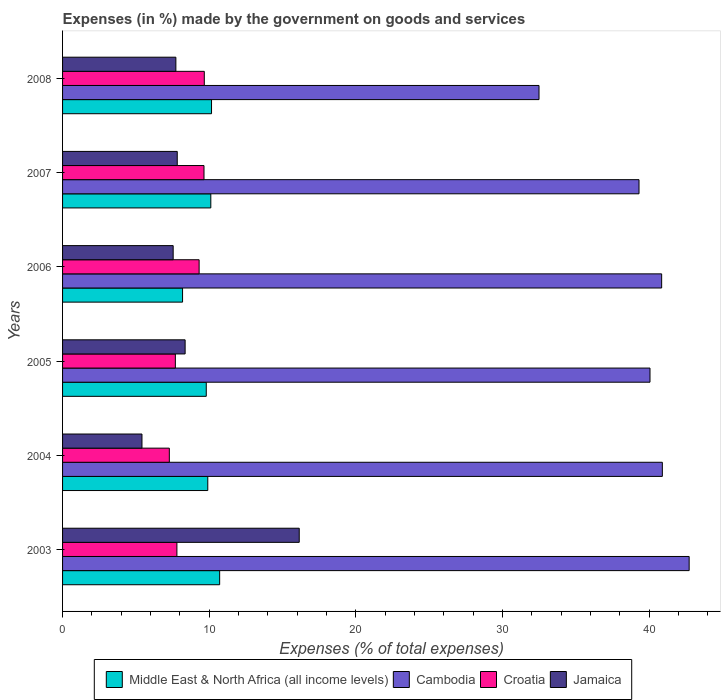How many different coloured bars are there?
Make the answer very short. 4. Are the number of bars per tick equal to the number of legend labels?
Your answer should be compact. Yes. How many bars are there on the 2nd tick from the top?
Provide a succinct answer. 4. What is the label of the 2nd group of bars from the top?
Provide a succinct answer. 2007. In how many cases, is the number of bars for a given year not equal to the number of legend labels?
Keep it short and to the point. 0. What is the percentage of expenses made by the government on goods and services in Croatia in 2006?
Your answer should be compact. 9.31. Across all years, what is the maximum percentage of expenses made by the government on goods and services in Jamaica?
Your answer should be very brief. 16.14. Across all years, what is the minimum percentage of expenses made by the government on goods and services in Middle East & North Africa (all income levels)?
Your answer should be very brief. 8.18. What is the total percentage of expenses made by the government on goods and services in Jamaica in the graph?
Ensure brevity in your answer.  52.99. What is the difference between the percentage of expenses made by the government on goods and services in Croatia in 2003 and that in 2004?
Make the answer very short. 0.52. What is the difference between the percentage of expenses made by the government on goods and services in Jamaica in 2004 and the percentage of expenses made by the government on goods and services in Croatia in 2007?
Your answer should be very brief. -4.23. What is the average percentage of expenses made by the government on goods and services in Jamaica per year?
Give a very brief answer. 8.83. In the year 2007, what is the difference between the percentage of expenses made by the government on goods and services in Croatia and percentage of expenses made by the government on goods and services in Middle East & North Africa (all income levels)?
Make the answer very short. -0.46. In how many years, is the percentage of expenses made by the government on goods and services in Cambodia greater than 20 %?
Ensure brevity in your answer.  6. What is the ratio of the percentage of expenses made by the government on goods and services in Cambodia in 2003 to that in 2008?
Offer a very short reply. 1.32. What is the difference between the highest and the second highest percentage of expenses made by the government on goods and services in Cambodia?
Make the answer very short. 1.83. What is the difference between the highest and the lowest percentage of expenses made by the government on goods and services in Croatia?
Offer a terse response. 2.38. In how many years, is the percentage of expenses made by the government on goods and services in Cambodia greater than the average percentage of expenses made by the government on goods and services in Cambodia taken over all years?
Make the answer very short. 4. Is the sum of the percentage of expenses made by the government on goods and services in Jamaica in 2005 and 2008 greater than the maximum percentage of expenses made by the government on goods and services in Cambodia across all years?
Your answer should be compact. No. Is it the case that in every year, the sum of the percentage of expenses made by the government on goods and services in Cambodia and percentage of expenses made by the government on goods and services in Croatia is greater than the sum of percentage of expenses made by the government on goods and services in Middle East & North Africa (all income levels) and percentage of expenses made by the government on goods and services in Jamaica?
Your answer should be very brief. Yes. What does the 1st bar from the top in 2007 represents?
Make the answer very short. Jamaica. What does the 1st bar from the bottom in 2007 represents?
Ensure brevity in your answer.  Middle East & North Africa (all income levels). How many bars are there?
Your response must be concise. 24. Are all the bars in the graph horizontal?
Provide a short and direct response. Yes. How are the legend labels stacked?
Keep it short and to the point. Horizontal. What is the title of the graph?
Ensure brevity in your answer.  Expenses (in %) made by the government on goods and services. What is the label or title of the X-axis?
Offer a very short reply. Expenses (% of total expenses). What is the label or title of the Y-axis?
Keep it short and to the point. Years. What is the Expenses (% of total expenses) in Middle East & North Africa (all income levels) in 2003?
Offer a very short reply. 10.71. What is the Expenses (% of total expenses) of Cambodia in 2003?
Provide a succinct answer. 42.72. What is the Expenses (% of total expenses) of Croatia in 2003?
Make the answer very short. 7.79. What is the Expenses (% of total expenses) of Jamaica in 2003?
Your answer should be compact. 16.14. What is the Expenses (% of total expenses) of Middle East & North Africa (all income levels) in 2004?
Offer a terse response. 9.9. What is the Expenses (% of total expenses) of Cambodia in 2004?
Provide a short and direct response. 40.89. What is the Expenses (% of total expenses) in Croatia in 2004?
Your response must be concise. 7.28. What is the Expenses (% of total expenses) of Jamaica in 2004?
Make the answer very short. 5.41. What is the Expenses (% of total expenses) of Middle East & North Africa (all income levels) in 2005?
Offer a very short reply. 9.8. What is the Expenses (% of total expenses) in Cambodia in 2005?
Your answer should be compact. 40.05. What is the Expenses (% of total expenses) of Croatia in 2005?
Your response must be concise. 7.69. What is the Expenses (% of total expenses) of Jamaica in 2005?
Your answer should be very brief. 8.36. What is the Expenses (% of total expenses) of Middle East & North Africa (all income levels) in 2006?
Give a very brief answer. 8.18. What is the Expenses (% of total expenses) of Cambodia in 2006?
Offer a very short reply. 40.84. What is the Expenses (% of total expenses) of Croatia in 2006?
Make the answer very short. 9.31. What is the Expenses (% of total expenses) in Jamaica in 2006?
Ensure brevity in your answer.  7.54. What is the Expenses (% of total expenses) in Middle East & North Africa (all income levels) in 2007?
Your answer should be compact. 10.11. What is the Expenses (% of total expenses) of Cambodia in 2007?
Your answer should be very brief. 39.3. What is the Expenses (% of total expenses) of Croatia in 2007?
Offer a very short reply. 9.64. What is the Expenses (% of total expenses) in Jamaica in 2007?
Make the answer very short. 7.82. What is the Expenses (% of total expenses) in Middle East & North Africa (all income levels) in 2008?
Offer a very short reply. 10.16. What is the Expenses (% of total expenses) in Cambodia in 2008?
Provide a short and direct response. 32.48. What is the Expenses (% of total expenses) in Croatia in 2008?
Your response must be concise. 9.66. What is the Expenses (% of total expenses) of Jamaica in 2008?
Ensure brevity in your answer.  7.72. Across all years, what is the maximum Expenses (% of total expenses) in Middle East & North Africa (all income levels)?
Provide a short and direct response. 10.71. Across all years, what is the maximum Expenses (% of total expenses) of Cambodia?
Keep it short and to the point. 42.72. Across all years, what is the maximum Expenses (% of total expenses) of Croatia?
Your answer should be compact. 9.66. Across all years, what is the maximum Expenses (% of total expenses) in Jamaica?
Your answer should be compact. 16.14. Across all years, what is the minimum Expenses (% of total expenses) in Middle East & North Africa (all income levels)?
Keep it short and to the point. 8.18. Across all years, what is the minimum Expenses (% of total expenses) of Cambodia?
Make the answer very short. 32.48. Across all years, what is the minimum Expenses (% of total expenses) in Croatia?
Make the answer very short. 7.28. Across all years, what is the minimum Expenses (% of total expenses) of Jamaica?
Provide a short and direct response. 5.41. What is the total Expenses (% of total expenses) of Middle East & North Africa (all income levels) in the graph?
Your answer should be compact. 58.85. What is the total Expenses (% of total expenses) of Cambodia in the graph?
Provide a short and direct response. 236.28. What is the total Expenses (% of total expenses) in Croatia in the graph?
Provide a succinct answer. 51.38. What is the total Expenses (% of total expenses) in Jamaica in the graph?
Offer a terse response. 52.99. What is the difference between the Expenses (% of total expenses) of Middle East & North Africa (all income levels) in 2003 and that in 2004?
Ensure brevity in your answer.  0.81. What is the difference between the Expenses (% of total expenses) in Cambodia in 2003 and that in 2004?
Offer a terse response. 1.83. What is the difference between the Expenses (% of total expenses) in Croatia in 2003 and that in 2004?
Ensure brevity in your answer.  0.52. What is the difference between the Expenses (% of total expenses) of Jamaica in 2003 and that in 2004?
Your answer should be very brief. 10.72. What is the difference between the Expenses (% of total expenses) in Middle East & North Africa (all income levels) in 2003 and that in 2005?
Ensure brevity in your answer.  0.91. What is the difference between the Expenses (% of total expenses) in Cambodia in 2003 and that in 2005?
Your response must be concise. 2.67. What is the difference between the Expenses (% of total expenses) of Croatia in 2003 and that in 2005?
Keep it short and to the point. 0.11. What is the difference between the Expenses (% of total expenses) in Jamaica in 2003 and that in 2005?
Your answer should be compact. 7.78. What is the difference between the Expenses (% of total expenses) in Middle East & North Africa (all income levels) in 2003 and that in 2006?
Your answer should be very brief. 2.53. What is the difference between the Expenses (% of total expenses) in Cambodia in 2003 and that in 2006?
Provide a short and direct response. 1.88. What is the difference between the Expenses (% of total expenses) of Croatia in 2003 and that in 2006?
Make the answer very short. -1.52. What is the difference between the Expenses (% of total expenses) of Jamaica in 2003 and that in 2006?
Provide a succinct answer. 8.59. What is the difference between the Expenses (% of total expenses) of Middle East & North Africa (all income levels) in 2003 and that in 2007?
Your answer should be compact. 0.6. What is the difference between the Expenses (% of total expenses) in Cambodia in 2003 and that in 2007?
Make the answer very short. 3.42. What is the difference between the Expenses (% of total expenses) of Croatia in 2003 and that in 2007?
Ensure brevity in your answer.  -1.85. What is the difference between the Expenses (% of total expenses) of Jamaica in 2003 and that in 2007?
Offer a very short reply. 8.32. What is the difference between the Expenses (% of total expenses) in Middle East & North Africa (all income levels) in 2003 and that in 2008?
Your answer should be compact. 0.55. What is the difference between the Expenses (% of total expenses) of Cambodia in 2003 and that in 2008?
Offer a terse response. 10.24. What is the difference between the Expenses (% of total expenses) in Croatia in 2003 and that in 2008?
Provide a succinct answer. -1.87. What is the difference between the Expenses (% of total expenses) of Jamaica in 2003 and that in 2008?
Your answer should be compact. 8.41. What is the difference between the Expenses (% of total expenses) of Middle East & North Africa (all income levels) in 2004 and that in 2005?
Make the answer very short. 0.1. What is the difference between the Expenses (% of total expenses) in Cambodia in 2004 and that in 2005?
Your answer should be very brief. 0.84. What is the difference between the Expenses (% of total expenses) of Croatia in 2004 and that in 2005?
Provide a short and direct response. -0.41. What is the difference between the Expenses (% of total expenses) of Jamaica in 2004 and that in 2005?
Keep it short and to the point. -2.94. What is the difference between the Expenses (% of total expenses) in Middle East & North Africa (all income levels) in 2004 and that in 2006?
Keep it short and to the point. 1.72. What is the difference between the Expenses (% of total expenses) of Cambodia in 2004 and that in 2006?
Provide a short and direct response. 0.05. What is the difference between the Expenses (% of total expenses) in Croatia in 2004 and that in 2006?
Offer a very short reply. -2.03. What is the difference between the Expenses (% of total expenses) in Jamaica in 2004 and that in 2006?
Offer a very short reply. -2.13. What is the difference between the Expenses (% of total expenses) in Middle East & North Africa (all income levels) in 2004 and that in 2007?
Give a very brief answer. -0.21. What is the difference between the Expenses (% of total expenses) in Cambodia in 2004 and that in 2007?
Your response must be concise. 1.59. What is the difference between the Expenses (% of total expenses) of Croatia in 2004 and that in 2007?
Your answer should be compact. -2.36. What is the difference between the Expenses (% of total expenses) in Jamaica in 2004 and that in 2007?
Provide a succinct answer. -2.4. What is the difference between the Expenses (% of total expenses) of Middle East & North Africa (all income levels) in 2004 and that in 2008?
Provide a short and direct response. -0.26. What is the difference between the Expenses (% of total expenses) in Cambodia in 2004 and that in 2008?
Give a very brief answer. 8.41. What is the difference between the Expenses (% of total expenses) in Croatia in 2004 and that in 2008?
Provide a succinct answer. -2.38. What is the difference between the Expenses (% of total expenses) in Jamaica in 2004 and that in 2008?
Keep it short and to the point. -2.31. What is the difference between the Expenses (% of total expenses) in Middle East & North Africa (all income levels) in 2005 and that in 2006?
Offer a very short reply. 1.62. What is the difference between the Expenses (% of total expenses) in Cambodia in 2005 and that in 2006?
Your answer should be very brief. -0.79. What is the difference between the Expenses (% of total expenses) of Croatia in 2005 and that in 2006?
Ensure brevity in your answer.  -1.62. What is the difference between the Expenses (% of total expenses) of Jamaica in 2005 and that in 2006?
Offer a terse response. 0.82. What is the difference between the Expenses (% of total expenses) of Middle East & North Africa (all income levels) in 2005 and that in 2007?
Give a very brief answer. -0.31. What is the difference between the Expenses (% of total expenses) of Cambodia in 2005 and that in 2007?
Your response must be concise. 0.75. What is the difference between the Expenses (% of total expenses) of Croatia in 2005 and that in 2007?
Make the answer very short. -1.95. What is the difference between the Expenses (% of total expenses) of Jamaica in 2005 and that in 2007?
Ensure brevity in your answer.  0.54. What is the difference between the Expenses (% of total expenses) of Middle East & North Africa (all income levels) in 2005 and that in 2008?
Your response must be concise. -0.36. What is the difference between the Expenses (% of total expenses) in Cambodia in 2005 and that in 2008?
Your answer should be very brief. 7.57. What is the difference between the Expenses (% of total expenses) of Croatia in 2005 and that in 2008?
Ensure brevity in your answer.  -1.97. What is the difference between the Expenses (% of total expenses) in Jamaica in 2005 and that in 2008?
Offer a terse response. 0.63. What is the difference between the Expenses (% of total expenses) in Middle East & North Africa (all income levels) in 2006 and that in 2007?
Your response must be concise. -1.93. What is the difference between the Expenses (% of total expenses) in Cambodia in 2006 and that in 2007?
Give a very brief answer. 1.54. What is the difference between the Expenses (% of total expenses) in Croatia in 2006 and that in 2007?
Give a very brief answer. -0.33. What is the difference between the Expenses (% of total expenses) of Jamaica in 2006 and that in 2007?
Give a very brief answer. -0.28. What is the difference between the Expenses (% of total expenses) in Middle East & North Africa (all income levels) in 2006 and that in 2008?
Provide a short and direct response. -1.98. What is the difference between the Expenses (% of total expenses) of Cambodia in 2006 and that in 2008?
Make the answer very short. 8.36. What is the difference between the Expenses (% of total expenses) in Croatia in 2006 and that in 2008?
Provide a short and direct response. -0.35. What is the difference between the Expenses (% of total expenses) in Jamaica in 2006 and that in 2008?
Offer a very short reply. -0.18. What is the difference between the Expenses (% of total expenses) in Middle East & North Africa (all income levels) in 2007 and that in 2008?
Provide a short and direct response. -0.05. What is the difference between the Expenses (% of total expenses) of Cambodia in 2007 and that in 2008?
Your answer should be compact. 6.82. What is the difference between the Expenses (% of total expenses) of Croatia in 2007 and that in 2008?
Your answer should be very brief. -0.02. What is the difference between the Expenses (% of total expenses) in Jamaica in 2007 and that in 2008?
Offer a very short reply. 0.09. What is the difference between the Expenses (% of total expenses) in Middle East & North Africa (all income levels) in 2003 and the Expenses (% of total expenses) in Cambodia in 2004?
Give a very brief answer. -30.18. What is the difference between the Expenses (% of total expenses) in Middle East & North Africa (all income levels) in 2003 and the Expenses (% of total expenses) in Croatia in 2004?
Your answer should be compact. 3.43. What is the difference between the Expenses (% of total expenses) of Middle East & North Africa (all income levels) in 2003 and the Expenses (% of total expenses) of Jamaica in 2004?
Your answer should be very brief. 5.3. What is the difference between the Expenses (% of total expenses) in Cambodia in 2003 and the Expenses (% of total expenses) in Croatia in 2004?
Provide a short and direct response. 35.44. What is the difference between the Expenses (% of total expenses) in Cambodia in 2003 and the Expenses (% of total expenses) in Jamaica in 2004?
Ensure brevity in your answer.  37.3. What is the difference between the Expenses (% of total expenses) of Croatia in 2003 and the Expenses (% of total expenses) of Jamaica in 2004?
Give a very brief answer. 2.38. What is the difference between the Expenses (% of total expenses) in Middle East & North Africa (all income levels) in 2003 and the Expenses (% of total expenses) in Cambodia in 2005?
Ensure brevity in your answer.  -29.34. What is the difference between the Expenses (% of total expenses) of Middle East & North Africa (all income levels) in 2003 and the Expenses (% of total expenses) of Croatia in 2005?
Make the answer very short. 3.02. What is the difference between the Expenses (% of total expenses) of Middle East & North Africa (all income levels) in 2003 and the Expenses (% of total expenses) of Jamaica in 2005?
Ensure brevity in your answer.  2.35. What is the difference between the Expenses (% of total expenses) in Cambodia in 2003 and the Expenses (% of total expenses) in Croatia in 2005?
Your answer should be very brief. 35.03. What is the difference between the Expenses (% of total expenses) in Cambodia in 2003 and the Expenses (% of total expenses) in Jamaica in 2005?
Your answer should be compact. 34.36. What is the difference between the Expenses (% of total expenses) of Croatia in 2003 and the Expenses (% of total expenses) of Jamaica in 2005?
Offer a very short reply. -0.56. What is the difference between the Expenses (% of total expenses) in Middle East & North Africa (all income levels) in 2003 and the Expenses (% of total expenses) in Cambodia in 2006?
Give a very brief answer. -30.13. What is the difference between the Expenses (% of total expenses) in Middle East & North Africa (all income levels) in 2003 and the Expenses (% of total expenses) in Croatia in 2006?
Ensure brevity in your answer.  1.4. What is the difference between the Expenses (% of total expenses) of Middle East & North Africa (all income levels) in 2003 and the Expenses (% of total expenses) of Jamaica in 2006?
Give a very brief answer. 3.17. What is the difference between the Expenses (% of total expenses) of Cambodia in 2003 and the Expenses (% of total expenses) of Croatia in 2006?
Give a very brief answer. 33.41. What is the difference between the Expenses (% of total expenses) in Cambodia in 2003 and the Expenses (% of total expenses) in Jamaica in 2006?
Your answer should be very brief. 35.18. What is the difference between the Expenses (% of total expenses) in Croatia in 2003 and the Expenses (% of total expenses) in Jamaica in 2006?
Provide a succinct answer. 0.25. What is the difference between the Expenses (% of total expenses) of Middle East & North Africa (all income levels) in 2003 and the Expenses (% of total expenses) of Cambodia in 2007?
Your response must be concise. -28.59. What is the difference between the Expenses (% of total expenses) of Middle East & North Africa (all income levels) in 2003 and the Expenses (% of total expenses) of Croatia in 2007?
Your response must be concise. 1.07. What is the difference between the Expenses (% of total expenses) in Middle East & North Africa (all income levels) in 2003 and the Expenses (% of total expenses) in Jamaica in 2007?
Your answer should be compact. 2.89. What is the difference between the Expenses (% of total expenses) in Cambodia in 2003 and the Expenses (% of total expenses) in Croatia in 2007?
Your answer should be very brief. 33.08. What is the difference between the Expenses (% of total expenses) of Cambodia in 2003 and the Expenses (% of total expenses) of Jamaica in 2007?
Ensure brevity in your answer.  34.9. What is the difference between the Expenses (% of total expenses) in Croatia in 2003 and the Expenses (% of total expenses) in Jamaica in 2007?
Offer a terse response. -0.02. What is the difference between the Expenses (% of total expenses) of Middle East & North Africa (all income levels) in 2003 and the Expenses (% of total expenses) of Cambodia in 2008?
Your answer should be very brief. -21.77. What is the difference between the Expenses (% of total expenses) in Middle East & North Africa (all income levels) in 2003 and the Expenses (% of total expenses) in Croatia in 2008?
Your response must be concise. 1.05. What is the difference between the Expenses (% of total expenses) of Middle East & North Africa (all income levels) in 2003 and the Expenses (% of total expenses) of Jamaica in 2008?
Offer a very short reply. 2.99. What is the difference between the Expenses (% of total expenses) in Cambodia in 2003 and the Expenses (% of total expenses) in Croatia in 2008?
Your answer should be very brief. 33.06. What is the difference between the Expenses (% of total expenses) in Cambodia in 2003 and the Expenses (% of total expenses) in Jamaica in 2008?
Provide a short and direct response. 34.99. What is the difference between the Expenses (% of total expenses) of Croatia in 2003 and the Expenses (% of total expenses) of Jamaica in 2008?
Offer a very short reply. 0.07. What is the difference between the Expenses (% of total expenses) in Middle East & North Africa (all income levels) in 2004 and the Expenses (% of total expenses) in Cambodia in 2005?
Your answer should be very brief. -30.15. What is the difference between the Expenses (% of total expenses) in Middle East & North Africa (all income levels) in 2004 and the Expenses (% of total expenses) in Croatia in 2005?
Provide a short and direct response. 2.21. What is the difference between the Expenses (% of total expenses) of Middle East & North Africa (all income levels) in 2004 and the Expenses (% of total expenses) of Jamaica in 2005?
Your response must be concise. 1.54. What is the difference between the Expenses (% of total expenses) of Cambodia in 2004 and the Expenses (% of total expenses) of Croatia in 2005?
Keep it short and to the point. 33.2. What is the difference between the Expenses (% of total expenses) in Cambodia in 2004 and the Expenses (% of total expenses) in Jamaica in 2005?
Your response must be concise. 32.53. What is the difference between the Expenses (% of total expenses) of Croatia in 2004 and the Expenses (% of total expenses) of Jamaica in 2005?
Ensure brevity in your answer.  -1.08. What is the difference between the Expenses (% of total expenses) of Middle East & North Africa (all income levels) in 2004 and the Expenses (% of total expenses) of Cambodia in 2006?
Make the answer very short. -30.94. What is the difference between the Expenses (% of total expenses) of Middle East & North Africa (all income levels) in 2004 and the Expenses (% of total expenses) of Croatia in 2006?
Provide a short and direct response. 0.59. What is the difference between the Expenses (% of total expenses) of Middle East & North Africa (all income levels) in 2004 and the Expenses (% of total expenses) of Jamaica in 2006?
Offer a very short reply. 2.36. What is the difference between the Expenses (% of total expenses) of Cambodia in 2004 and the Expenses (% of total expenses) of Croatia in 2006?
Make the answer very short. 31.58. What is the difference between the Expenses (% of total expenses) of Cambodia in 2004 and the Expenses (% of total expenses) of Jamaica in 2006?
Give a very brief answer. 33.35. What is the difference between the Expenses (% of total expenses) in Croatia in 2004 and the Expenses (% of total expenses) in Jamaica in 2006?
Keep it short and to the point. -0.26. What is the difference between the Expenses (% of total expenses) of Middle East & North Africa (all income levels) in 2004 and the Expenses (% of total expenses) of Cambodia in 2007?
Make the answer very short. -29.4. What is the difference between the Expenses (% of total expenses) in Middle East & North Africa (all income levels) in 2004 and the Expenses (% of total expenses) in Croatia in 2007?
Give a very brief answer. 0.26. What is the difference between the Expenses (% of total expenses) in Middle East & North Africa (all income levels) in 2004 and the Expenses (% of total expenses) in Jamaica in 2007?
Your response must be concise. 2.08. What is the difference between the Expenses (% of total expenses) of Cambodia in 2004 and the Expenses (% of total expenses) of Croatia in 2007?
Keep it short and to the point. 31.25. What is the difference between the Expenses (% of total expenses) of Cambodia in 2004 and the Expenses (% of total expenses) of Jamaica in 2007?
Offer a very short reply. 33.07. What is the difference between the Expenses (% of total expenses) in Croatia in 2004 and the Expenses (% of total expenses) in Jamaica in 2007?
Keep it short and to the point. -0.54. What is the difference between the Expenses (% of total expenses) of Middle East & North Africa (all income levels) in 2004 and the Expenses (% of total expenses) of Cambodia in 2008?
Ensure brevity in your answer.  -22.58. What is the difference between the Expenses (% of total expenses) in Middle East & North Africa (all income levels) in 2004 and the Expenses (% of total expenses) in Croatia in 2008?
Your response must be concise. 0.24. What is the difference between the Expenses (% of total expenses) of Middle East & North Africa (all income levels) in 2004 and the Expenses (% of total expenses) of Jamaica in 2008?
Ensure brevity in your answer.  2.18. What is the difference between the Expenses (% of total expenses) of Cambodia in 2004 and the Expenses (% of total expenses) of Croatia in 2008?
Your response must be concise. 31.23. What is the difference between the Expenses (% of total expenses) of Cambodia in 2004 and the Expenses (% of total expenses) of Jamaica in 2008?
Your response must be concise. 33.17. What is the difference between the Expenses (% of total expenses) of Croatia in 2004 and the Expenses (% of total expenses) of Jamaica in 2008?
Ensure brevity in your answer.  -0.45. What is the difference between the Expenses (% of total expenses) of Middle East & North Africa (all income levels) in 2005 and the Expenses (% of total expenses) of Cambodia in 2006?
Your response must be concise. -31.05. What is the difference between the Expenses (% of total expenses) of Middle East & North Africa (all income levels) in 2005 and the Expenses (% of total expenses) of Croatia in 2006?
Provide a succinct answer. 0.49. What is the difference between the Expenses (% of total expenses) in Middle East & North Africa (all income levels) in 2005 and the Expenses (% of total expenses) in Jamaica in 2006?
Provide a short and direct response. 2.26. What is the difference between the Expenses (% of total expenses) in Cambodia in 2005 and the Expenses (% of total expenses) in Croatia in 2006?
Make the answer very short. 30.74. What is the difference between the Expenses (% of total expenses) of Cambodia in 2005 and the Expenses (% of total expenses) of Jamaica in 2006?
Provide a short and direct response. 32.51. What is the difference between the Expenses (% of total expenses) in Croatia in 2005 and the Expenses (% of total expenses) in Jamaica in 2006?
Your answer should be very brief. 0.15. What is the difference between the Expenses (% of total expenses) in Middle East & North Africa (all income levels) in 2005 and the Expenses (% of total expenses) in Cambodia in 2007?
Your answer should be compact. -29.5. What is the difference between the Expenses (% of total expenses) of Middle East & North Africa (all income levels) in 2005 and the Expenses (% of total expenses) of Croatia in 2007?
Your response must be concise. 0.15. What is the difference between the Expenses (% of total expenses) of Middle East & North Africa (all income levels) in 2005 and the Expenses (% of total expenses) of Jamaica in 2007?
Keep it short and to the point. 1.98. What is the difference between the Expenses (% of total expenses) in Cambodia in 2005 and the Expenses (% of total expenses) in Croatia in 2007?
Keep it short and to the point. 30.41. What is the difference between the Expenses (% of total expenses) in Cambodia in 2005 and the Expenses (% of total expenses) in Jamaica in 2007?
Provide a short and direct response. 32.23. What is the difference between the Expenses (% of total expenses) in Croatia in 2005 and the Expenses (% of total expenses) in Jamaica in 2007?
Offer a terse response. -0.13. What is the difference between the Expenses (% of total expenses) of Middle East & North Africa (all income levels) in 2005 and the Expenses (% of total expenses) of Cambodia in 2008?
Your response must be concise. -22.69. What is the difference between the Expenses (% of total expenses) in Middle East & North Africa (all income levels) in 2005 and the Expenses (% of total expenses) in Croatia in 2008?
Your answer should be very brief. 0.13. What is the difference between the Expenses (% of total expenses) in Middle East & North Africa (all income levels) in 2005 and the Expenses (% of total expenses) in Jamaica in 2008?
Keep it short and to the point. 2.07. What is the difference between the Expenses (% of total expenses) of Cambodia in 2005 and the Expenses (% of total expenses) of Croatia in 2008?
Give a very brief answer. 30.39. What is the difference between the Expenses (% of total expenses) in Cambodia in 2005 and the Expenses (% of total expenses) in Jamaica in 2008?
Keep it short and to the point. 32.32. What is the difference between the Expenses (% of total expenses) in Croatia in 2005 and the Expenses (% of total expenses) in Jamaica in 2008?
Offer a very short reply. -0.03. What is the difference between the Expenses (% of total expenses) in Middle East & North Africa (all income levels) in 2006 and the Expenses (% of total expenses) in Cambodia in 2007?
Ensure brevity in your answer.  -31.12. What is the difference between the Expenses (% of total expenses) in Middle East & North Africa (all income levels) in 2006 and the Expenses (% of total expenses) in Croatia in 2007?
Provide a succinct answer. -1.46. What is the difference between the Expenses (% of total expenses) in Middle East & North Africa (all income levels) in 2006 and the Expenses (% of total expenses) in Jamaica in 2007?
Offer a very short reply. 0.36. What is the difference between the Expenses (% of total expenses) in Cambodia in 2006 and the Expenses (% of total expenses) in Croatia in 2007?
Provide a short and direct response. 31.2. What is the difference between the Expenses (% of total expenses) in Cambodia in 2006 and the Expenses (% of total expenses) in Jamaica in 2007?
Provide a short and direct response. 33.02. What is the difference between the Expenses (% of total expenses) of Croatia in 2006 and the Expenses (% of total expenses) of Jamaica in 2007?
Give a very brief answer. 1.49. What is the difference between the Expenses (% of total expenses) of Middle East & North Africa (all income levels) in 2006 and the Expenses (% of total expenses) of Cambodia in 2008?
Make the answer very short. -24.3. What is the difference between the Expenses (% of total expenses) in Middle East & North Africa (all income levels) in 2006 and the Expenses (% of total expenses) in Croatia in 2008?
Make the answer very short. -1.48. What is the difference between the Expenses (% of total expenses) of Middle East & North Africa (all income levels) in 2006 and the Expenses (% of total expenses) of Jamaica in 2008?
Provide a succinct answer. 0.46. What is the difference between the Expenses (% of total expenses) of Cambodia in 2006 and the Expenses (% of total expenses) of Croatia in 2008?
Ensure brevity in your answer.  31.18. What is the difference between the Expenses (% of total expenses) of Cambodia in 2006 and the Expenses (% of total expenses) of Jamaica in 2008?
Your answer should be compact. 33.12. What is the difference between the Expenses (% of total expenses) of Croatia in 2006 and the Expenses (% of total expenses) of Jamaica in 2008?
Your answer should be compact. 1.59. What is the difference between the Expenses (% of total expenses) of Middle East & North Africa (all income levels) in 2007 and the Expenses (% of total expenses) of Cambodia in 2008?
Provide a short and direct response. -22.38. What is the difference between the Expenses (% of total expenses) of Middle East & North Africa (all income levels) in 2007 and the Expenses (% of total expenses) of Croatia in 2008?
Keep it short and to the point. 0.44. What is the difference between the Expenses (% of total expenses) of Middle East & North Africa (all income levels) in 2007 and the Expenses (% of total expenses) of Jamaica in 2008?
Provide a short and direct response. 2.38. What is the difference between the Expenses (% of total expenses) of Cambodia in 2007 and the Expenses (% of total expenses) of Croatia in 2008?
Offer a terse response. 29.64. What is the difference between the Expenses (% of total expenses) in Cambodia in 2007 and the Expenses (% of total expenses) in Jamaica in 2008?
Your answer should be compact. 31.58. What is the difference between the Expenses (% of total expenses) of Croatia in 2007 and the Expenses (% of total expenses) of Jamaica in 2008?
Ensure brevity in your answer.  1.92. What is the average Expenses (% of total expenses) in Middle East & North Africa (all income levels) per year?
Ensure brevity in your answer.  9.81. What is the average Expenses (% of total expenses) in Cambodia per year?
Offer a very short reply. 39.38. What is the average Expenses (% of total expenses) of Croatia per year?
Ensure brevity in your answer.  8.56. What is the average Expenses (% of total expenses) of Jamaica per year?
Provide a succinct answer. 8.83. In the year 2003, what is the difference between the Expenses (% of total expenses) in Middle East & North Africa (all income levels) and Expenses (% of total expenses) in Cambodia?
Provide a short and direct response. -32.01. In the year 2003, what is the difference between the Expenses (% of total expenses) in Middle East & North Africa (all income levels) and Expenses (% of total expenses) in Croatia?
Make the answer very short. 2.92. In the year 2003, what is the difference between the Expenses (% of total expenses) in Middle East & North Africa (all income levels) and Expenses (% of total expenses) in Jamaica?
Keep it short and to the point. -5.43. In the year 2003, what is the difference between the Expenses (% of total expenses) of Cambodia and Expenses (% of total expenses) of Croatia?
Your response must be concise. 34.92. In the year 2003, what is the difference between the Expenses (% of total expenses) in Cambodia and Expenses (% of total expenses) in Jamaica?
Keep it short and to the point. 26.58. In the year 2003, what is the difference between the Expenses (% of total expenses) in Croatia and Expenses (% of total expenses) in Jamaica?
Give a very brief answer. -8.34. In the year 2004, what is the difference between the Expenses (% of total expenses) in Middle East & North Africa (all income levels) and Expenses (% of total expenses) in Cambodia?
Provide a succinct answer. -30.99. In the year 2004, what is the difference between the Expenses (% of total expenses) in Middle East & North Africa (all income levels) and Expenses (% of total expenses) in Croatia?
Make the answer very short. 2.62. In the year 2004, what is the difference between the Expenses (% of total expenses) of Middle East & North Africa (all income levels) and Expenses (% of total expenses) of Jamaica?
Offer a terse response. 4.49. In the year 2004, what is the difference between the Expenses (% of total expenses) of Cambodia and Expenses (% of total expenses) of Croatia?
Your response must be concise. 33.61. In the year 2004, what is the difference between the Expenses (% of total expenses) in Cambodia and Expenses (% of total expenses) in Jamaica?
Provide a short and direct response. 35.48. In the year 2004, what is the difference between the Expenses (% of total expenses) in Croatia and Expenses (% of total expenses) in Jamaica?
Your response must be concise. 1.86. In the year 2005, what is the difference between the Expenses (% of total expenses) of Middle East & North Africa (all income levels) and Expenses (% of total expenses) of Cambodia?
Make the answer very short. -30.25. In the year 2005, what is the difference between the Expenses (% of total expenses) of Middle East & North Africa (all income levels) and Expenses (% of total expenses) of Croatia?
Provide a succinct answer. 2.11. In the year 2005, what is the difference between the Expenses (% of total expenses) of Middle East & North Africa (all income levels) and Expenses (% of total expenses) of Jamaica?
Ensure brevity in your answer.  1.44. In the year 2005, what is the difference between the Expenses (% of total expenses) of Cambodia and Expenses (% of total expenses) of Croatia?
Offer a very short reply. 32.36. In the year 2005, what is the difference between the Expenses (% of total expenses) of Cambodia and Expenses (% of total expenses) of Jamaica?
Your response must be concise. 31.69. In the year 2005, what is the difference between the Expenses (% of total expenses) in Croatia and Expenses (% of total expenses) in Jamaica?
Make the answer very short. -0.67. In the year 2006, what is the difference between the Expenses (% of total expenses) in Middle East & North Africa (all income levels) and Expenses (% of total expenses) in Cambodia?
Offer a terse response. -32.66. In the year 2006, what is the difference between the Expenses (% of total expenses) of Middle East & North Africa (all income levels) and Expenses (% of total expenses) of Croatia?
Give a very brief answer. -1.13. In the year 2006, what is the difference between the Expenses (% of total expenses) of Middle East & North Africa (all income levels) and Expenses (% of total expenses) of Jamaica?
Offer a terse response. 0.64. In the year 2006, what is the difference between the Expenses (% of total expenses) of Cambodia and Expenses (% of total expenses) of Croatia?
Make the answer very short. 31.53. In the year 2006, what is the difference between the Expenses (% of total expenses) in Cambodia and Expenses (% of total expenses) in Jamaica?
Offer a terse response. 33.3. In the year 2006, what is the difference between the Expenses (% of total expenses) of Croatia and Expenses (% of total expenses) of Jamaica?
Your answer should be compact. 1.77. In the year 2007, what is the difference between the Expenses (% of total expenses) of Middle East & North Africa (all income levels) and Expenses (% of total expenses) of Cambodia?
Make the answer very short. -29.19. In the year 2007, what is the difference between the Expenses (% of total expenses) in Middle East & North Africa (all income levels) and Expenses (% of total expenses) in Croatia?
Offer a very short reply. 0.46. In the year 2007, what is the difference between the Expenses (% of total expenses) in Middle East & North Africa (all income levels) and Expenses (% of total expenses) in Jamaica?
Keep it short and to the point. 2.29. In the year 2007, what is the difference between the Expenses (% of total expenses) of Cambodia and Expenses (% of total expenses) of Croatia?
Keep it short and to the point. 29.66. In the year 2007, what is the difference between the Expenses (% of total expenses) in Cambodia and Expenses (% of total expenses) in Jamaica?
Make the answer very short. 31.48. In the year 2007, what is the difference between the Expenses (% of total expenses) of Croatia and Expenses (% of total expenses) of Jamaica?
Your answer should be very brief. 1.82. In the year 2008, what is the difference between the Expenses (% of total expenses) of Middle East & North Africa (all income levels) and Expenses (% of total expenses) of Cambodia?
Your answer should be compact. -22.33. In the year 2008, what is the difference between the Expenses (% of total expenses) of Middle East & North Africa (all income levels) and Expenses (% of total expenses) of Croatia?
Offer a terse response. 0.49. In the year 2008, what is the difference between the Expenses (% of total expenses) of Middle East & North Africa (all income levels) and Expenses (% of total expenses) of Jamaica?
Offer a terse response. 2.43. In the year 2008, what is the difference between the Expenses (% of total expenses) in Cambodia and Expenses (% of total expenses) in Croatia?
Offer a terse response. 22.82. In the year 2008, what is the difference between the Expenses (% of total expenses) in Cambodia and Expenses (% of total expenses) in Jamaica?
Your response must be concise. 24.76. In the year 2008, what is the difference between the Expenses (% of total expenses) in Croatia and Expenses (% of total expenses) in Jamaica?
Keep it short and to the point. 1.94. What is the ratio of the Expenses (% of total expenses) of Middle East & North Africa (all income levels) in 2003 to that in 2004?
Provide a short and direct response. 1.08. What is the ratio of the Expenses (% of total expenses) of Cambodia in 2003 to that in 2004?
Offer a very short reply. 1.04. What is the ratio of the Expenses (% of total expenses) of Croatia in 2003 to that in 2004?
Offer a very short reply. 1.07. What is the ratio of the Expenses (% of total expenses) of Jamaica in 2003 to that in 2004?
Offer a very short reply. 2.98. What is the ratio of the Expenses (% of total expenses) in Middle East & North Africa (all income levels) in 2003 to that in 2005?
Keep it short and to the point. 1.09. What is the ratio of the Expenses (% of total expenses) of Cambodia in 2003 to that in 2005?
Your answer should be very brief. 1.07. What is the ratio of the Expenses (% of total expenses) in Croatia in 2003 to that in 2005?
Your answer should be very brief. 1.01. What is the ratio of the Expenses (% of total expenses) of Jamaica in 2003 to that in 2005?
Your answer should be very brief. 1.93. What is the ratio of the Expenses (% of total expenses) of Middle East & North Africa (all income levels) in 2003 to that in 2006?
Make the answer very short. 1.31. What is the ratio of the Expenses (% of total expenses) of Cambodia in 2003 to that in 2006?
Keep it short and to the point. 1.05. What is the ratio of the Expenses (% of total expenses) in Croatia in 2003 to that in 2006?
Provide a short and direct response. 0.84. What is the ratio of the Expenses (% of total expenses) of Jamaica in 2003 to that in 2006?
Provide a short and direct response. 2.14. What is the ratio of the Expenses (% of total expenses) of Middle East & North Africa (all income levels) in 2003 to that in 2007?
Offer a terse response. 1.06. What is the ratio of the Expenses (% of total expenses) in Cambodia in 2003 to that in 2007?
Offer a very short reply. 1.09. What is the ratio of the Expenses (% of total expenses) of Croatia in 2003 to that in 2007?
Provide a succinct answer. 0.81. What is the ratio of the Expenses (% of total expenses) in Jamaica in 2003 to that in 2007?
Offer a terse response. 2.06. What is the ratio of the Expenses (% of total expenses) of Middle East & North Africa (all income levels) in 2003 to that in 2008?
Provide a short and direct response. 1.05. What is the ratio of the Expenses (% of total expenses) of Cambodia in 2003 to that in 2008?
Your response must be concise. 1.32. What is the ratio of the Expenses (% of total expenses) of Croatia in 2003 to that in 2008?
Offer a terse response. 0.81. What is the ratio of the Expenses (% of total expenses) of Jamaica in 2003 to that in 2008?
Your answer should be compact. 2.09. What is the ratio of the Expenses (% of total expenses) in Middle East & North Africa (all income levels) in 2004 to that in 2005?
Offer a terse response. 1.01. What is the ratio of the Expenses (% of total expenses) of Croatia in 2004 to that in 2005?
Offer a terse response. 0.95. What is the ratio of the Expenses (% of total expenses) in Jamaica in 2004 to that in 2005?
Offer a very short reply. 0.65. What is the ratio of the Expenses (% of total expenses) of Middle East & North Africa (all income levels) in 2004 to that in 2006?
Provide a succinct answer. 1.21. What is the ratio of the Expenses (% of total expenses) of Cambodia in 2004 to that in 2006?
Your response must be concise. 1. What is the ratio of the Expenses (% of total expenses) of Croatia in 2004 to that in 2006?
Your response must be concise. 0.78. What is the ratio of the Expenses (% of total expenses) in Jamaica in 2004 to that in 2006?
Ensure brevity in your answer.  0.72. What is the ratio of the Expenses (% of total expenses) in Middle East & North Africa (all income levels) in 2004 to that in 2007?
Your answer should be very brief. 0.98. What is the ratio of the Expenses (% of total expenses) in Cambodia in 2004 to that in 2007?
Your answer should be compact. 1.04. What is the ratio of the Expenses (% of total expenses) in Croatia in 2004 to that in 2007?
Make the answer very short. 0.75. What is the ratio of the Expenses (% of total expenses) of Jamaica in 2004 to that in 2007?
Give a very brief answer. 0.69. What is the ratio of the Expenses (% of total expenses) in Middle East & North Africa (all income levels) in 2004 to that in 2008?
Provide a short and direct response. 0.97. What is the ratio of the Expenses (% of total expenses) of Cambodia in 2004 to that in 2008?
Provide a succinct answer. 1.26. What is the ratio of the Expenses (% of total expenses) of Croatia in 2004 to that in 2008?
Make the answer very short. 0.75. What is the ratio of the Expenses (% of total expenses) in Jamaica in 2004 to that in 2008?
Provide a succinct answer. 0.7. What is the ratio of the Expenses (% of total expenses) in Middle East & North Africa (all income levels) in 2005 to that in 2006?
Make the answer very short. 1.2. What is the ratio of the Expenses (% of total expenses) of Cambodia in 2005 to that in 2006?
Keep it short and to the point. 0.98. What is the ratio of the Expenses (% of total expenses) of Croatia in 2005 to that in 2006?
Your answer should be compact. 0.83. What is the ratio of the Expenses (% of total expenses) of Jamaica in 2005 to that in 2006?
Offer a very short reply. 1.11. What is the ratio of the Expenses (% of total expenses) in Middle East & North Africa (all income levels) in 2005 to that in 2007?
Your answer should be compact. 0.97. What is the ratio of the Expenses (% of total expenses) in Cambodia in 2005 to that in 2007?
Your response must be concise. 1.02. What is the ratio of the Expenses (% of total expenses) in Croatia in 2005 to that in 2007?
Provide a short and direct response. 0.8. What is the ratio of the Expenses (% of total expenses) in Jamaica in 2005 to that in 2007?
Provide a succinct answer. 1.07. What is the ratio of the Expenses (% of total expenses) of Middle East & North Africa (all income levels) in 2005 to that in 2008?
Keep it short and to the point. 0.96. What is the ratio of the Expenses (% of total expenses) of Cambodia in 2005 to that in 2008?
Keep it short and to the point. 1.23. What is the ratio of the Expenses (% of total expenses) of Croatia in 2005 to that in 2008?
Your response must be concise. 0.8. What is the ratio of the Expenses (% of total expenses) in Jamaica in 2005 to that in 2008?
Keep it short and to the point. 1.08. What is the ratio of the Expenses (% of total expenses) of Middle East & North Africa (all income levels) in 2006 to that in 2007?
Keep it short and to the point. 0.81. What is the ratio of the Expenses (% of total expenses) of Cambodia in 2006 to that in 2007?
Your response must be concise. 1.04. What is the ratio of the Expenses (% of total expenses) in Croatia in 2006 to that in 2007?
Provide a short and direct response. 0.97. What is the ratio of the Expenses (% of total expenses) of Jamaica in 2006 to that in 2007?
Offer a very short reply. 0.96. What is the ratio of the Expenses (% of total expenses) in Middle East & North Africa (all income levels) in 2006 to that in 2008?
Make the answer very short. 0.81. What is the ratio of the Expenses (% of total expenses) of Cambodia in 2006 to that in 2008?
Keep it short and to the point. 1.26. What is the ratio of the Expenses (% of total expenses) of Croatia in 2006 to that in 2008?
Offer a very short reply. 0.96. What is the ratio of the Expenses (% of total expenses) of Jamaica in 2006 to that in 2008?
Ensure brevity in your answer.  0.98. What is the ratio of the Expenses (% of total expenses) of Middle East & North Africa (all income levels) in 2007 to that in 2008?
Your response must be concise. 1. What is the ratio of the Expenses (% of total expenses) in Cambodia in 2007 to that in 2008?
Your answer should be very brief. 1.21. What is the ratio of the Expenses (% of total expenses) in Croatia in 2007 to that in 2008?
Ensure brevity in your answer.  1. What is the ratio of the Expenses (% of total expenses) in Jamaica in 2007 to that in 2008?
Your answer should be very brief. 1.01. What is the difference between the highest and the second highest Expenses (% of total expenses) in Middle East & North Africa (all income levels)?
Offer a terse response. 0.55. What is the difference between the highest and the second highest Expenses (% of total expenses) in Cambodia?
Offer a very short reply. 1.83. What is the difference between the highest and the second highest Expenses (% of total expenses) of Croatia?
Offer a terse response. 0.02. What is the difference between the highest and the second highest Expenses (% of total expenses) of Jamaica?
Give a very brief answer. 7.78. What is the difference between the highest and the lowest Expenses (% of total expenses) in Middle East & North Africa (all income levels)?
Provide a succinct answer. 2.53. What is the difference between the highest and the lowest Expenses (% of total expenses) of Cambodia?
Ensure brevity in your answer.  10.24. What is the difference between the highest and the lowest Expenses (% of total expenses) in Croatia?
Your response must be concise. 2.38. What is the difference between the highest and the lowest Expenses (% of total expenses) of Jamaica?
Provide a succinct answer. 10.72. 